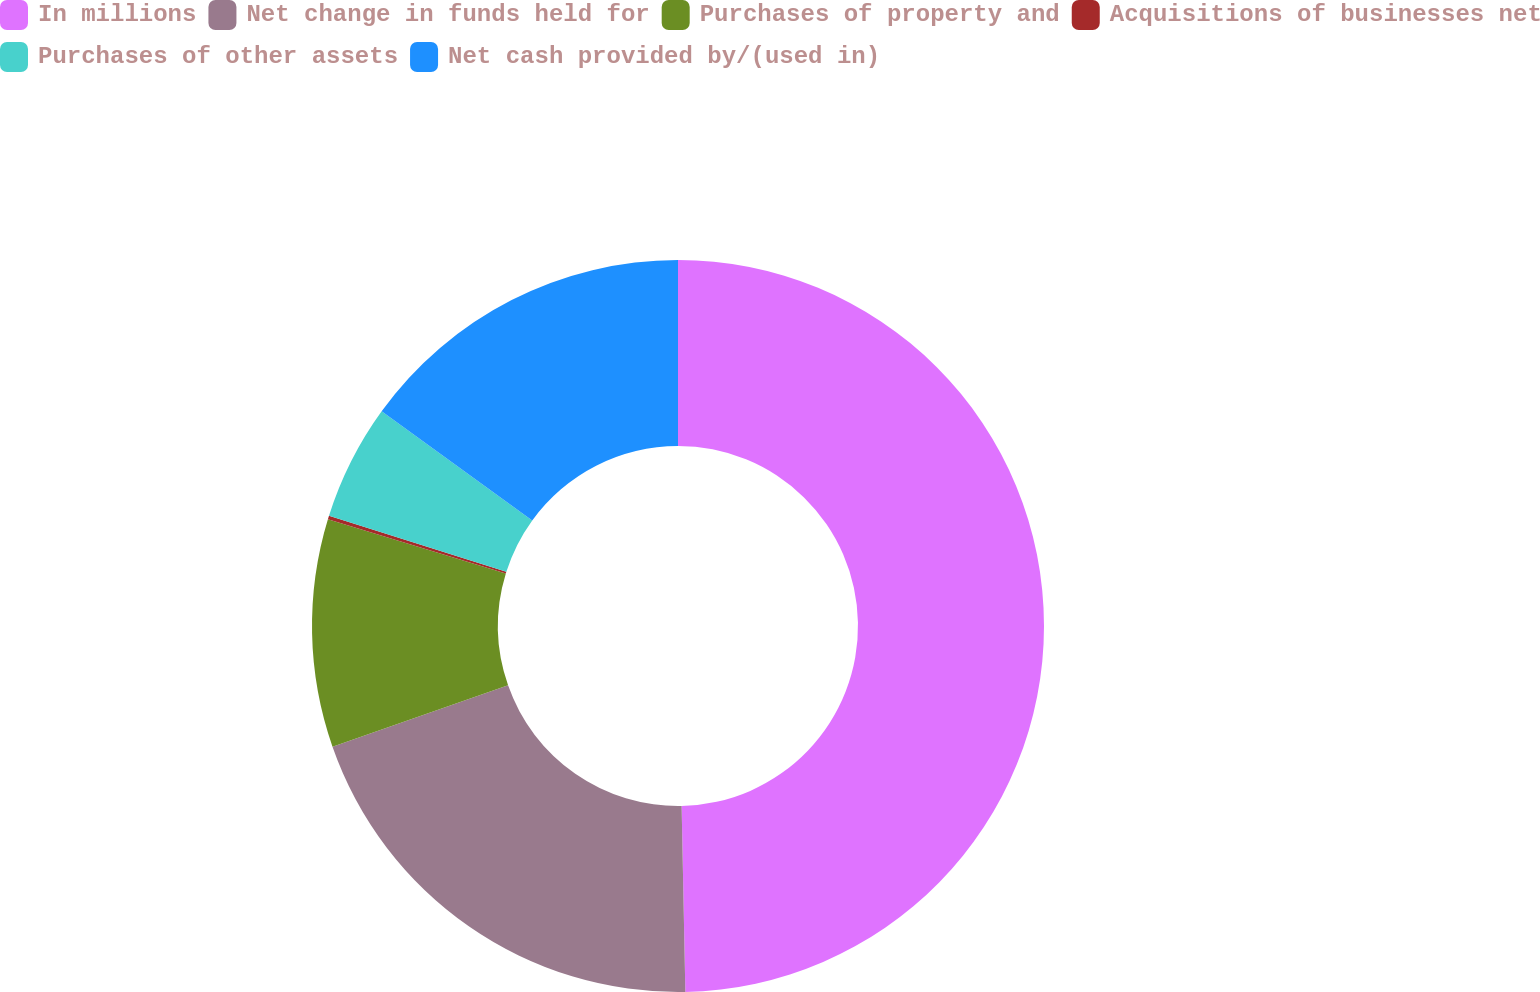Convert chart to OTSL. <chart><loc_0><loc_0><loc_500><loc_500><pie_chart><fcel>In millions<fcel>Net change in funds held for<fcel>Purchases of property and<fcel>Acquisitions of businesses net<fcel>Purchases of other assets<fcel>Net cash provided by/(used in)<nl><fcel>49.68%<fcel>19.97%<fcel>10.06%<fcel>0.16%<fcel>5.11%<fcel>15.02%<nl></chart> 